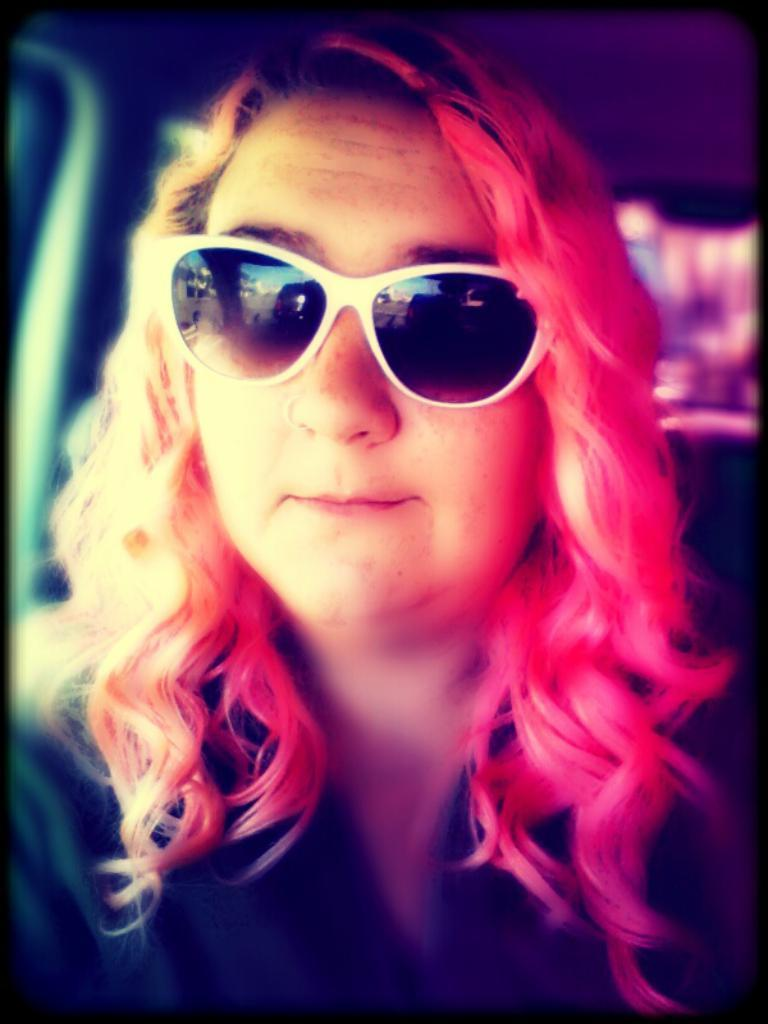Who is the main subject in the image? There is a woman in the image. What is the woman wearing on her face? The woman is wearing goggles. What can be seen on the goggles? There are reflections of objects on the goggles. How would you describe the background of the image? The background of the image is blurry. What type of books can be seen in the woman's elbow in the image? There are no books or elbows visible in the image; the woman is wearing goggles and the background is blurry. 